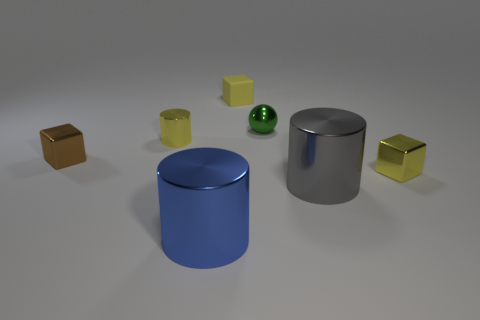Add 1 metal cylinders. How many objects exist? 8 Subtract all cylinders. How many objects are left? 4 Add 1 yellow metallic cylinders. How many yellow metallic cylinders are left? 2 Add 2 brown metal things. How many brown metal things exist? 3 Subtract 1 green spheres. How many objects are left? 6 Subtract all tiny metallic balls. Subtract all tiny gray metal cubes. How many objects are left? 6 